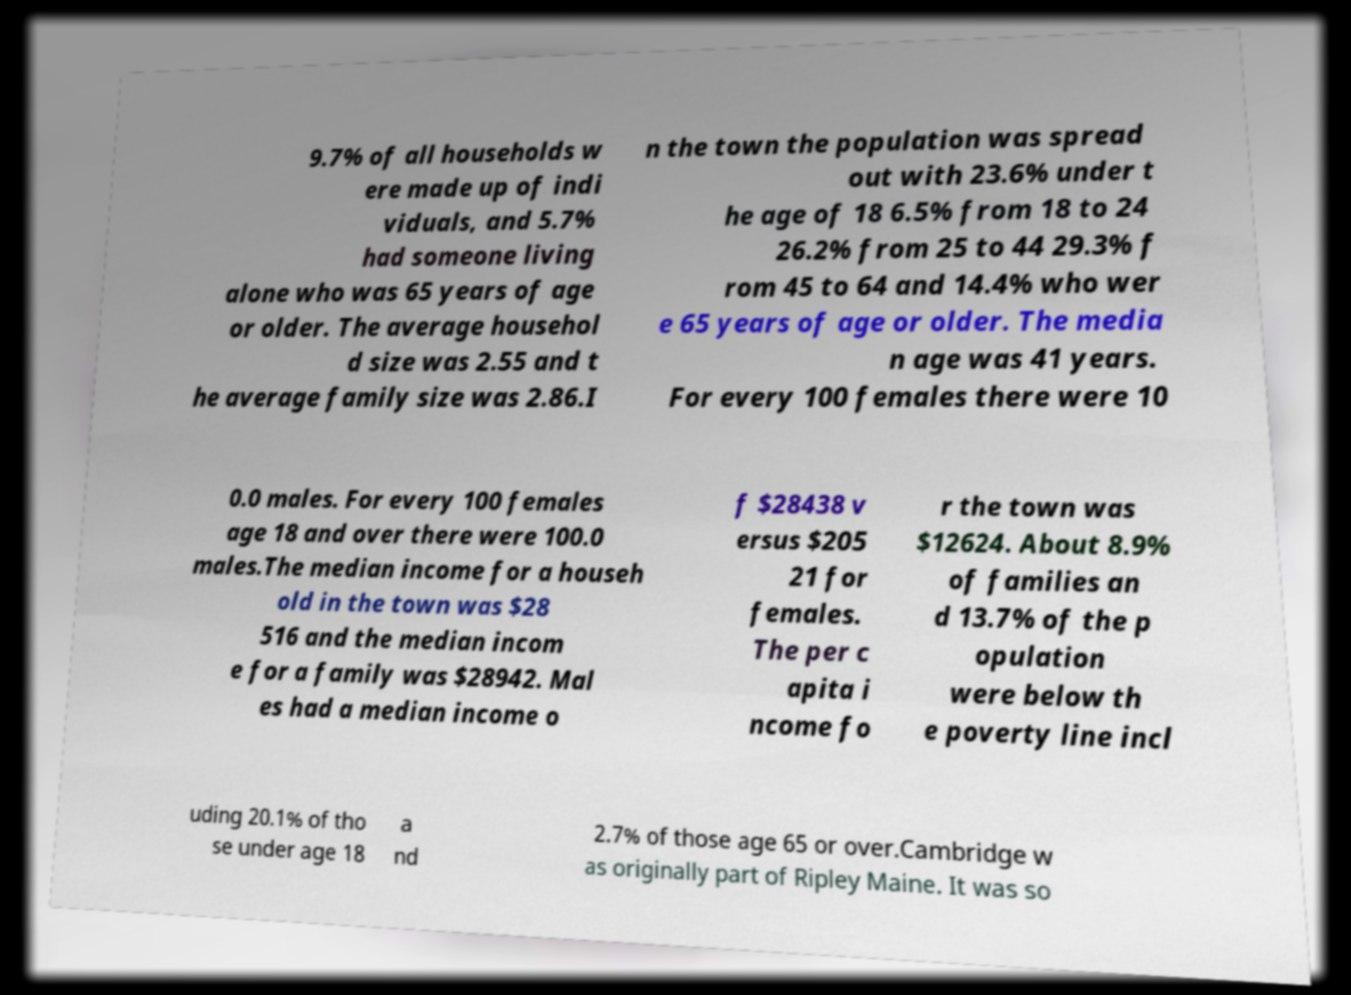What messages or text are displayed in this image? I need them in a readable, typed format. 9.7% of all households w ere made up of indi viduals, and 5.7% had someone living alone who was 65 years of age or older. The average househol d size was 2.55 and t he average family size was 2.86.I n the town the population was spread out with 23.6% under t he age of 18 6.5% from 18 to 24 26.2% from 25 to 44 29.3% f rom 45 to 64 and 14.4% who wer e 65 years of age or older. The media n age was 41 years. For every 100 females there were 10 0.0 males. For every 100 females age 18 and over there were 100.0 males.The median income for a househ old in the town was $28 516 and the median incom e for a family was $28942. Mal es had a median income o f $28438 v ersus $205 21 for females. The per c apita i ncome fo r the town was $12624. About 8.9% of families an d 13.7% of the p opulation were below th e poverty line incl uding 20.1% of tho se under age 18 a nd 2.7% of those age 65 or over.Cambridge w as originally part of Ripley Maine. It was so 